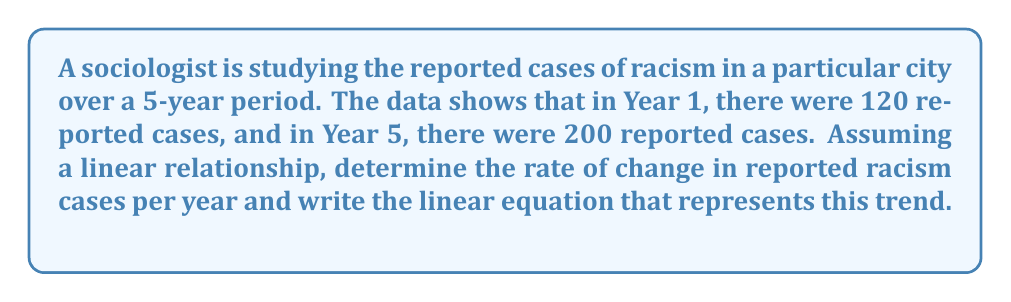Solve this math problem. To solve this problem, we'll use the point-slope form of a linear equation and calculate the rate of change (slope) between two given points.

1. Identify the two points:
   Point 1: $(x_1, y_1) = (1, 120)$
   Point 2: $(x_2, y_2) = (5, 200)$

2. Calculate the slope (rate of change) using the formula:
   $$m = \frac{y_2 - y_1}{x_2 - x_1} = \frac{200 - 120}{5 - 1} = \frac{80}{4} = 20$$

   This means the rate of change is 20 reported cases per year.

3. Use the point-slope form of a linear equation:
   $$y - y_1 = m(x - x_1)$$

   Let's use Point 1 $(1, 120)$:
   $$y - 120 = 20(x - 1)$$

4. Simplify the equation:
   $$y - 120 = 20x - 20$$
   $$y = 20x - 20 + 120$$
   $$y = 20x + 100$$

This linear equation represents the trend of reported racism cases over time, where $x$ is the year (with Year 1 as $x = 1$) and $y$ is the number of reported cases.
Answer: The rate of change is 20 reported racism cases per year, and the linear equation is $y = 20x + 100$, where $x$ is the year (starting with Year 1 as $x = 1$) and $y$ is the number of reported cases. 